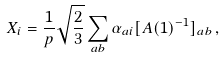<formula> <loc_0><loc_0><loc_500><loc_500>X _ { i } = \frac { 1 } { p } \sqrt { \frac { 2 } { 3 } } \sum _ { a b } \alpha _ { a i } [ A ( 1 ) ^ { - 1 } ] _ { a b } \, ,</formula> 